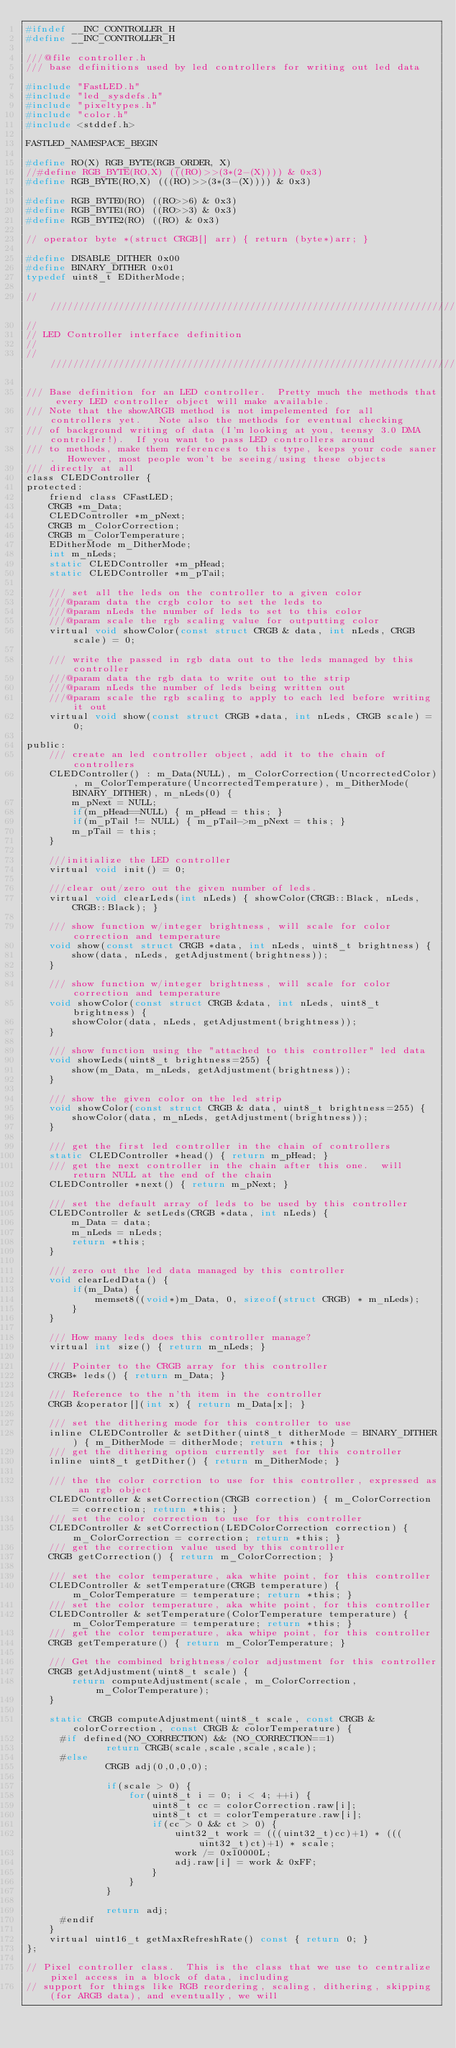Convert code to text. <code><loc_0><loc_0><loc_500><loc_500><_C_>#ifndef __INC_CONTROLLER_H
#define __INC_CONTROLLER_H

///@file controller.h
/// base definitions used by led controllers for writing out led data

#include "FastLED.h"
#include "led_sysdefs.h"
#include "pixeltypes.h"
#include "color.h"
#include <stddef.h>

FASTLED_NAMESPACE_BEGIN

#define RO(X) RGB_BYTE(RGB_ORDER, X)
//#define RGB_BYTE(RO,X) (((RO)>>(3*(2-(X)))) & 0x3)
#define RGB_BYTE(RO,X) (((RO)>>(3*(3-(X)))) & 0x3)

#define RGB_BYTE0(RO) ((RO>>6) & 0x3)
#define RGB_BYTE1(RO) ((RO>>3) & 0x3)
#define RGB_BYTE2(RO) ((RO) & 0x3)

// operator byte *(struct CRGB[] arr) { return (byte*)arr; }

#define DISABLE_DITHER 0x00
#define BINARY_DITHER 0x01
typedef uint8_t EDitherMode;

//////////////////////////////////////////////////////////////////////////////////////////////////////////////////////////////////
//
// LED Controller interface definition
//
//////////////////////////////////////////////////////////////////////////////////////////////////////////////////////////////////

/// Base definition for an LED controller.  Pretty much the methods that every LED controller object will make available.
/// Note that the showARGB method is not impelemented for all controllers yet.   Note also the methods for eventual checking
/// of background writing of data (I'm looking at you, teensy 3.0 DMA controller!).  If you want to pass LED controllers around
/// to methods, make them references to this type, keeps your code saner.  However, most people won't be seeing/using these objects
/// directly at all
class CLEDController {
protected:
    friend class CFastLED;
    CRGB *m_Data;
    CLEDController *m_pNext;
    CRGB m_ColorCorrection;
    CRGB m_ColorTemperature;
    EDitherMode m_DitherMode;
    int m_nLeds;
    static CLEDController *m_pHead;
    static CLEDController *m_pTail;

    /// set all the leds on the controller to a given color
    ///@param data the crgb color to set the leds to
    ///@param nLeds the number of leds to set to this color
    ///@param scale the rgb scaling value for outputting color
    virtual void showColor(const struct CRGB & data, int nLeds, CRGB scale) = 0;

	/// write the passed in rgb data out to the leds managed by this controller
	///@param data the rgb data to write out to the strip
	///@param nLeds the number of leds being written out
	///@param scale the rgb scaling to apply to each led before writing it out
    virtual void show(const struct CRGB *data, int nLeds, CRGB scale) = 0;

public:
	/// create an led controller object, add it to the chain of controllers
    CLEDController() : m_Data(NULL), m_ColorCorrection(UncorrectedColor), m_ColorTemperature(UncorrectedTemperature), m_DitherMode(BINARY_DITHER), m_nLeds(0) {
        m_pNext = NULL;
        if(m_pHead==NULL) { m_pHead = this; }
        if(m_pTail != NULL) { m_pTail->m_pNext = this; }
        m_pTail = this;
    }

	///initialize the LED controller
	virtual void init() = 0;

	///clear out/zero out the given number of leds.
	virtual void clearLeds(int nLeds) { showColor(CRGB::Black, nLeds, CRGB::Black); }

    /// show function w/integer brightness, will scale for color correction and temperature
    void show(const struct CRGB *data, int nLeds, uint8_t brightness) {
        show(data, nLeds, getAdjustment(brightness));
    }

    /// show function w/integer brightness, will scale for color correction and temperature
    void showColor(const struct CRGB &data, int nLeds, uint8_t brightness) {
        showColor(data, nLeds, getAdjustment(brightness));
    }

    /// show function using the "attached to this controller" led data
    void showLeds(uint8_t brightness=255) {
        show(m_Data, m_nLeds, getAdjustment(brightness));
    }

	/// show the given color on the led strip
    void showColor(const struct CRGB & data, uint8_t brightness=255) {
        showColor(data, m_nLeds, getAdjustment(brightness));
    }

    /// get the first led controller in the chain of controllers
    static CLEDController *head() { return m_pHead; }
    /// get the next controller in the chain after this one.  will return NULL at the end of the chain
    CLEDController *next() { return m_pNext; }

	/// set the default array of leds to be used by this controller
    CLEDController & setLeds(CRGB *data, int nLeds) {
        m_Data = data;
        m_nLeds = nLeds;
        return *this;
    }

	/// zero out the led data managed by this controller
    void clearLedData() {
        if(m_Data) {
            memset8((void*)m_Data, 0, sizeof(struct CRGB) * m_nLeds);
        }
    }

    /// How many leds does this controller manage?
    virtual int size() { return m_nLeds; }

    /// Pointer to the CRGB array for this controller
    CRGB* leds() { return m_Data; }

    /// Reference to the n'th item in the controller
    CRGB &operator[](int x) { return m_Data[x]; }

	/// set the dithering mode for this controller to use
    inline CLEDController & setDither(uint8_t ditherMode = BINARY_DITHER) { m_DitherMode = ditherMode; return *this; }
    /// get the dithering option currently set for this controller
    inline uint8_t getDither() { return m_DitherMode; }

	/// the the color corrction to use for this controller, expressed as an rgb object
    CLEDController & setCorrection(CRGB correction) { m_ColorCorrection = correction; return *this; }
    /// set the color correction to use for this controller
    CLEDController & setCorrection(LEDColorCorrection correction) { m_ColorCorrection = correction; return *this; }
    /// get the correction value used by this controller
    CRGB getCorrection() { return m_ColorCorrection; }

	/// set the color temperature, aka white point, for this controller
    CLEDController & setTemperature(CRGB temperature) { m_ColorTemperature = temperature; return *this; }
    /// set the color temperature, aka white point, for this controller
    CLEDController & setTemperature(ColorTemperature temperature) { m_ColorTemperature = temperature; return *this; }
    /// get the color temperature, aka whipe point, for this controller
    CRGB getTemperature() { return m_ColorTemperature; }

	/// Get the combined brightness/color adjustment for this controller
    CRGB getAdjustment(uint8_t scale) {
        return computeAdjustment(scale, m_ColorCorrection, m_ColorTemperature);
    }

    static CRGB computeAdjustment(uint8_t scale, const CRGB & colorCorrection, const CRGB & colorTemperature) {
      #if defined(NO_CORRECTION) && (NO_CORRECTION==1)
              return CRGB(scale,scale,scale,scale);
      #else
              CRGB adj(0,0,0,0);

              if(scale > 0) {
                  for(uint8_t i = 0; i < 4; ++i) {
                      uint8_t cc = colorCorrection.raw[i];
                      uint8_t ct = colorTemperature.raw[i];
                      if(cc > 0 && ct > 0) {
                          uint32_t work = (((uint32_t)cc)+1) * (((uint32_t)ct)+1) * scale;
                          work /= 0x10000L;
                          adj.raw[i] = work & 0xFF;
                      }
                  }
              }

              return adj;
      #endif
    }
    virtual uint16_t getMaxRefreshRate() const { return 0; }
};

// Pixel controller class.  This is the class that we use to centralize pixel access in a block of data, including
// support for things like RGB reordering, scaling, dithering, skipping (for ARGB data), and eventually, we will</code> 